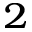Convert formula to latex. <formula><loc_0><loc_0><loc_500><loc_500>^ { 2 }</formula> 